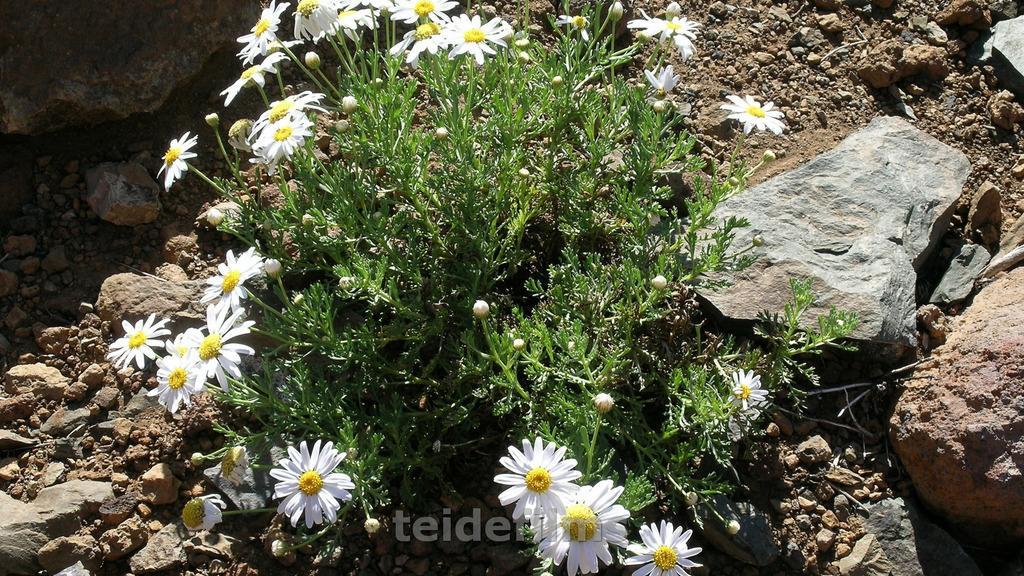Describe this image in one or two sentences. In this picture we can see plants, flowers, rocks and stones. 